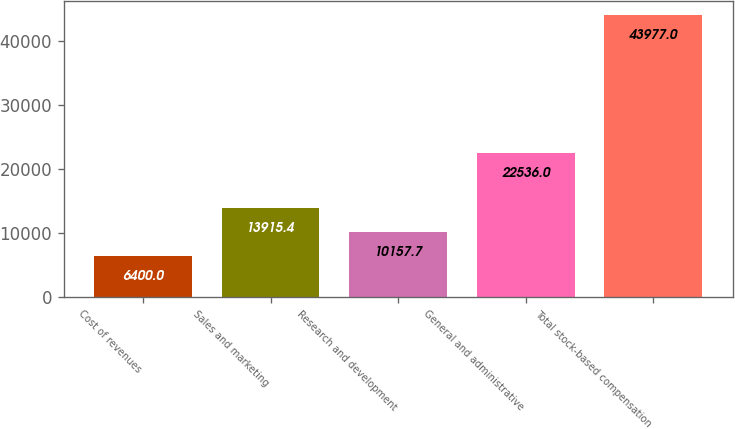<chart> <loc_0><loc_0><loc_500><loc_500><bar_chart><fcel>Cost of revenues<fcel>Sales and marketing<fcel>Research and development<fcel>General and administrative<fcel>Total stock-based compensation<nl><fcel>6400<fcel>13915.4<fcel>10157.7<fcel>22536<fcel>43977<nl></chart> 